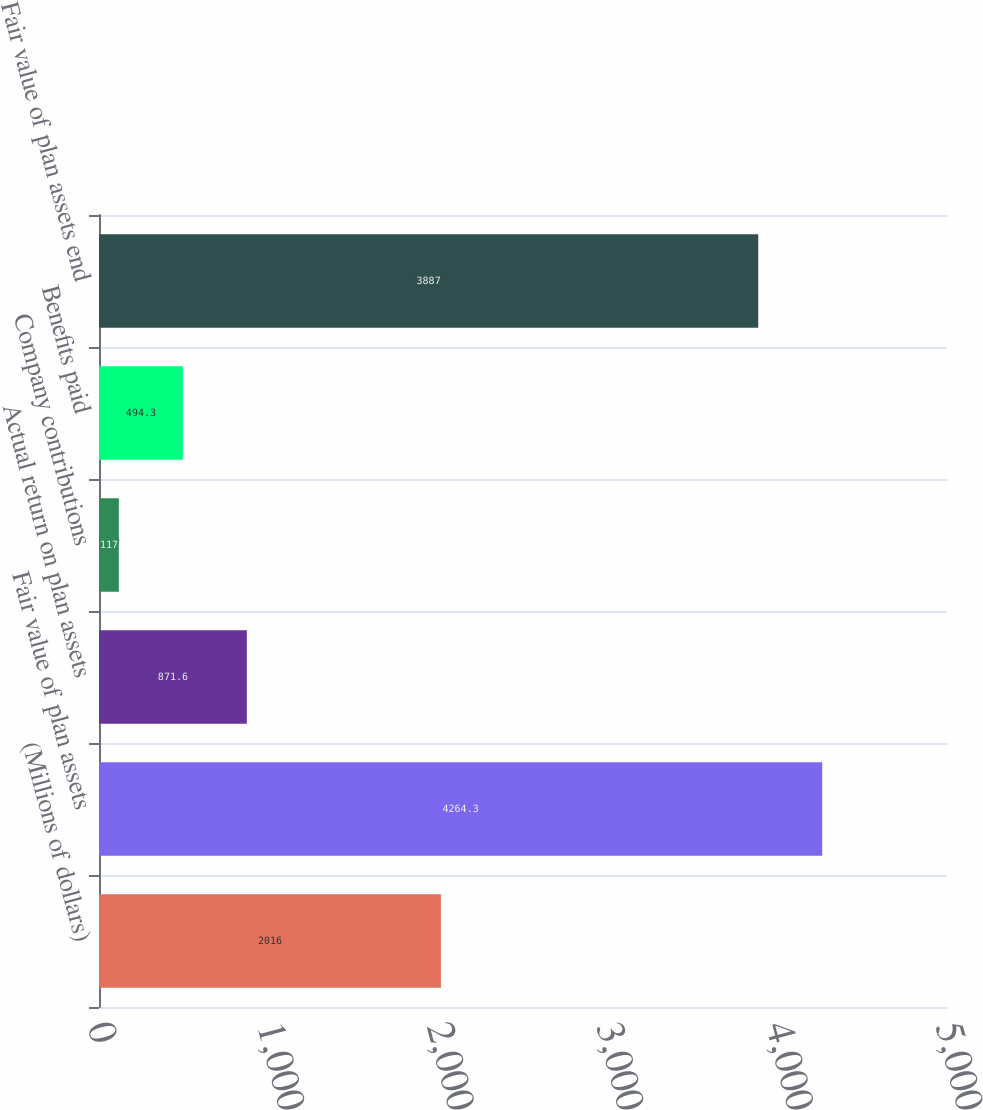Convert chart to OTSL. <chart><loc_0><loc_0><loc_500><loc_500><bar_chart><fcel>(Millions of dollars)<fcel>Fair value of plan assets<fcel>Actual return on plan assets<fcel>Company contributions<fcel>Benefits paid<fcel>Fair value of plan assets end<nl><fcel>2016<fcel>4264.3<fcel>871.6<fcel>117<fcel>494.3<fcel>3887<nl></chart> 